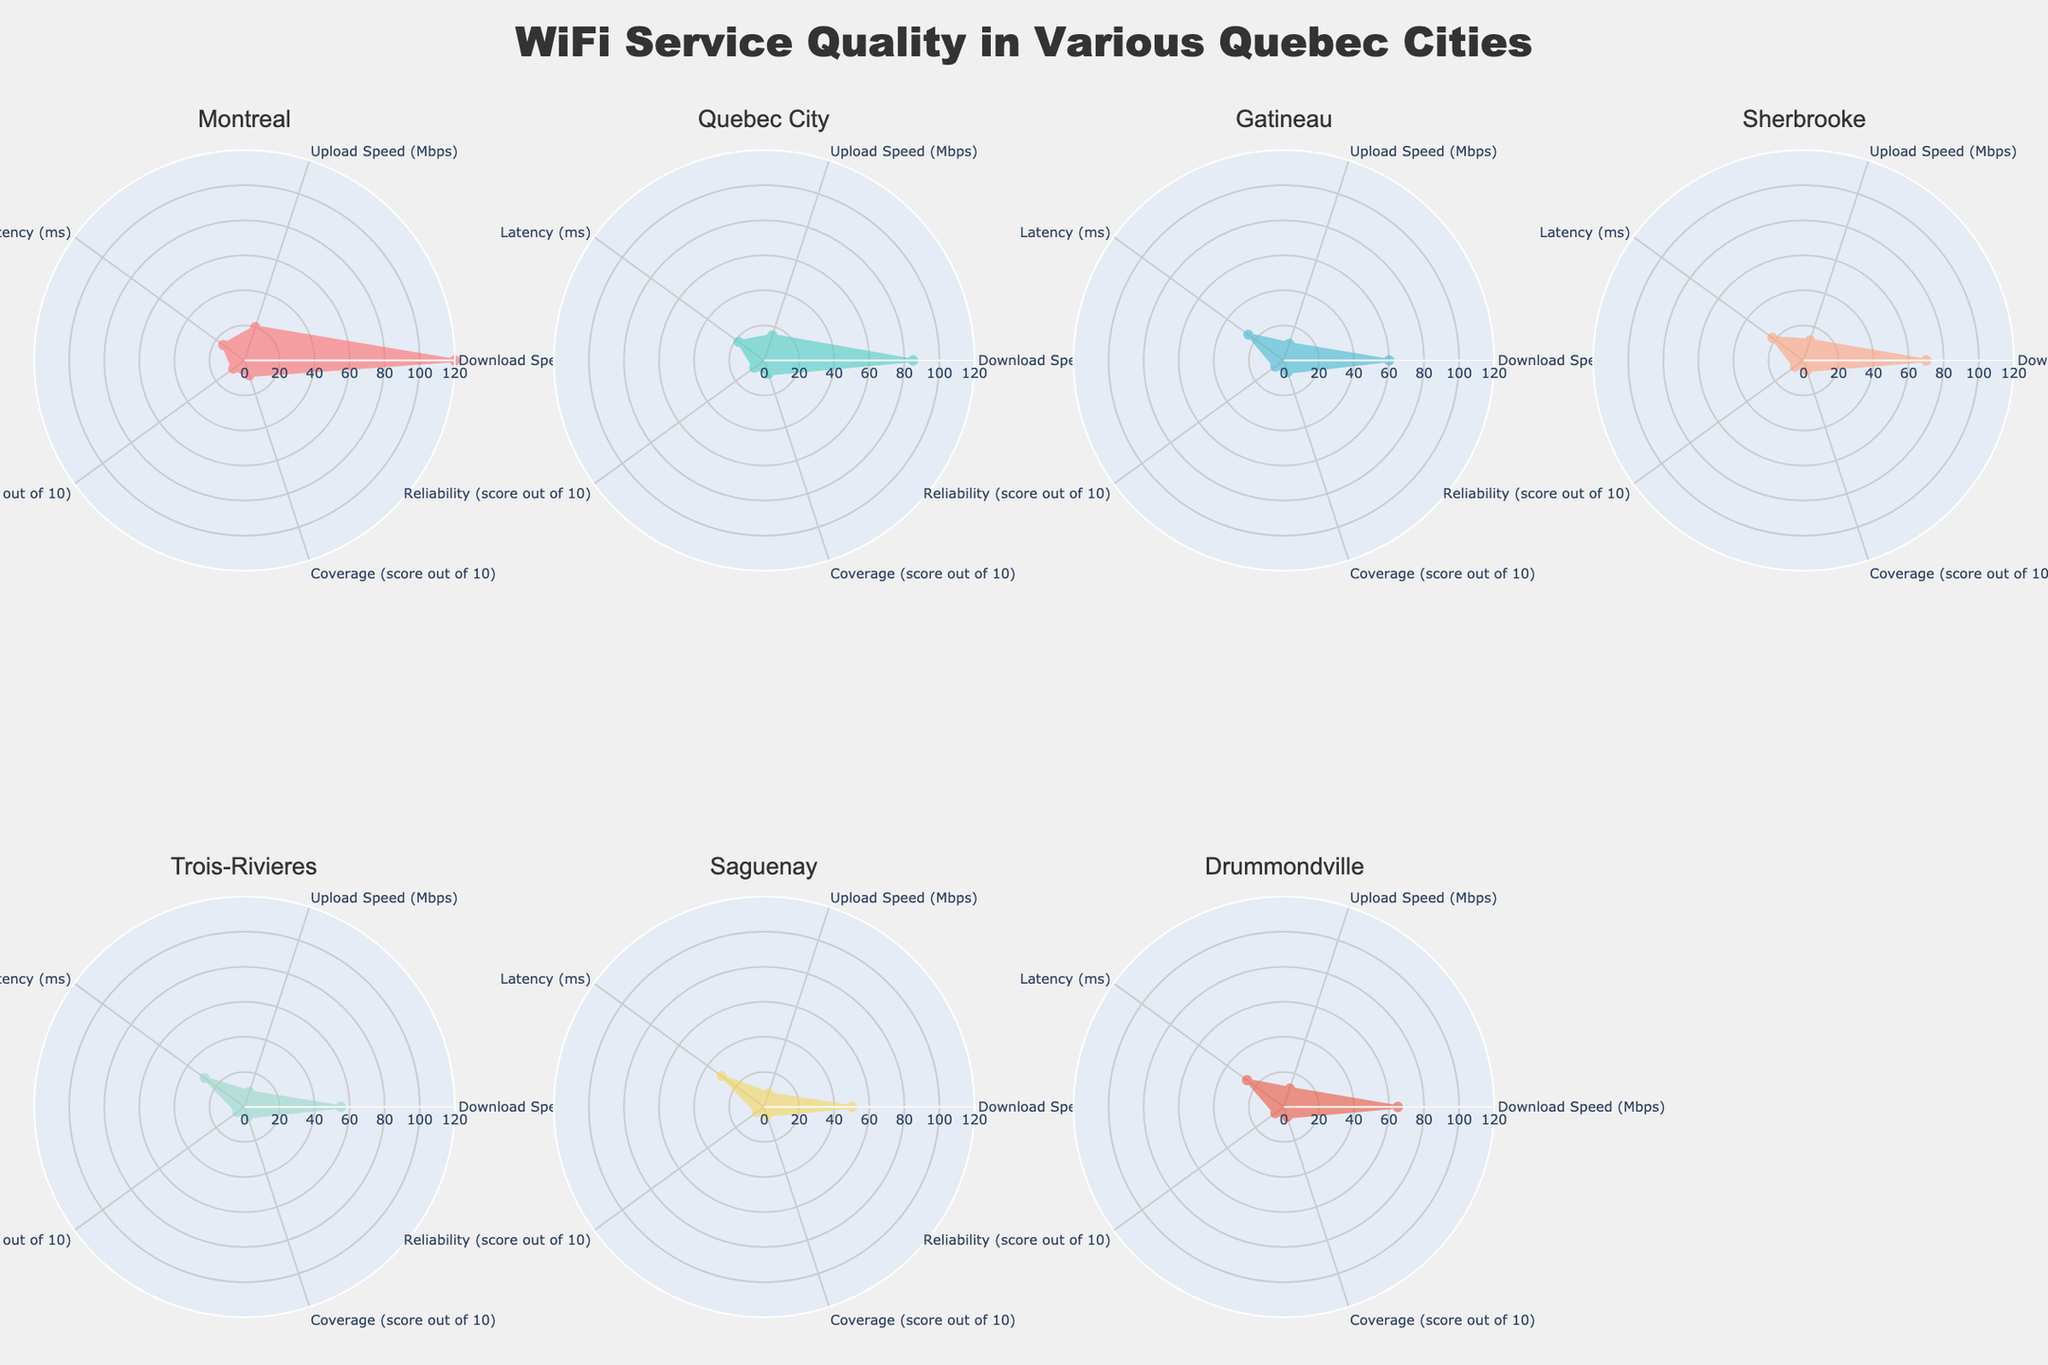What is the title of the radar chart? The title is prominently displayed at the top of the figure.
Answer: WiFi Service Quality in Various Quebec Cities Which city has the highest download speed? By inspecting the radar charts, Montreal has the highest download speed as it reaches the outermost ring in that section.
Answer: Montreal What is the average download speed of all cities combined? Adding up all the download speeds: 120 + 85 + 60 + 70 + 55 + 50 + 65 and dividing by 7 results in the average. (120 + 85 + 60 + 70 + 55 + 50 + 65)/7 = 72.14
Answer: 72.14 Mbps How does Latency in Gatineau compare to Montreal? By comparing the Latency sections of the radar charts for Gatineau and Montreal, Gatineau has a higher latency.
Answer: Gatineau has higher latency Which city has the least coverage score? The city with the radar chart that has the innermost point in the Coverage section has the least coverage score. Saguenay has the lowest value of 5 in this section.
Answer: Saguenay Which city has the best balance in WiFi service attributes without any extreme highs or lows? By examining the radar charts, Quebec City appears to maintain a balanced shape without extreme highs or lows.
Answer: Quebec City What is the difference in reliability scores between Sherbrooke and Trois-Rivieres? By looking at the reliability sections of the radar charts, Sherbrooke has a score of 6 and Trois-Rivieres has a score of 5. The difference is 6-5.
Answer: 1 Which cities have the lowest upload speeds? The upload speed section of the radar charts shows Drummondville and Saguenay as the cities with the lowest values. However, Saguenay has an upload speed of 8 Mbps while Drummondville has 11 Mbps. Therefore, Saguenay has the lowest.
Answer: Saguenay How many categories are represented in each radar chart? Each radar chart includes sections for download speed, upload speed, latency, reliability, and coverage, making it a total of 5 categories.
Answer: 5 